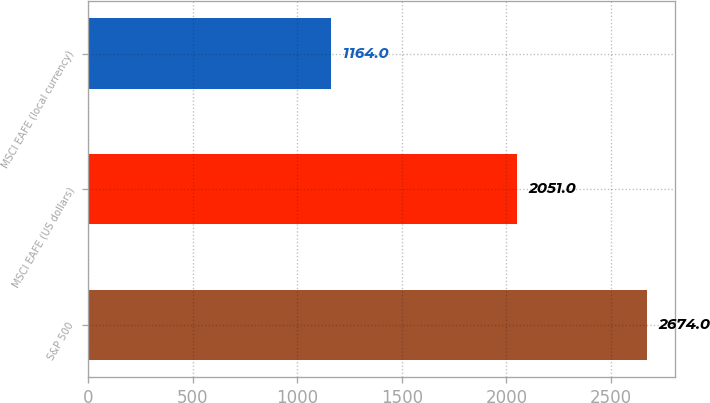Convert chart. <chart><loc_0><loc_0><loc_500><loc_500><bar_chart><fcel>S&P 500<fcel>MSCI EAFE (US dollars)<fcel>MSCI EAFE (local currency)<nl><fcel>2674<fcel>2051<fcel>1164<nl></chart> 